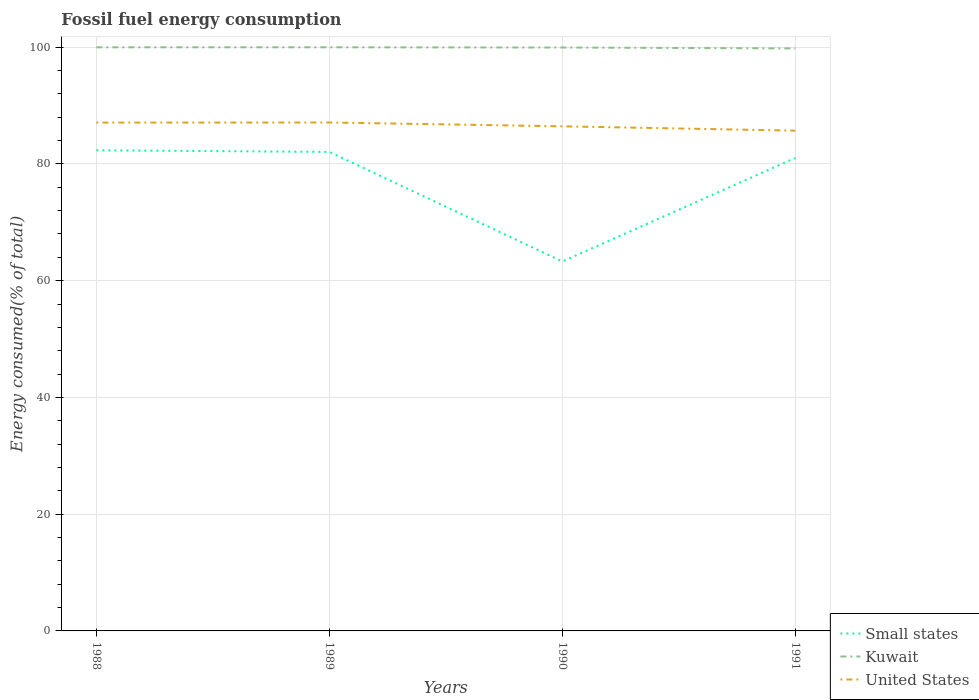How many different coloured lines are there?
Give a very brief answer. 3. Across all years, what is the maximum percentage of energy consumed in United States?
Provide a succinct answer. 85.69. In which year was the percentage of energy consumed in United States maximum?
Ensure brevity in your answer.  1991. What is the total percentage of energy consumed in Small states in the graph?
Your answer should be compact. 19.04. What is the difference between the highest and the second highest percentage of energy consumed in United States?
Your response must be concise. 1.4. What is the difference between the highest and the lowest percentage of energy consumed in Small states?
Provide a succinct answer. 3. How many lines are there?
Keep it short and to the point. 3. How many years are there in the graph?
Make the answer very short. 4. Where does the legend appear in the graph?
Your response must be concise. Bottom right. What is the title of the graph?
Keep it short and to the point. Fossil fuel energy consumption. Does "Macao" appear as one of the legend labels in the graph?
Keep it short and to the point. No. What is the label or title of the X-axis?
Offer a terse response. Years. What is the label or title of the Y-axis?
Offer a terse response. Energy consumed(% of total). What is the Energy consumed(% of total) of Small states in 1988?
Your answer should be compact. 82.33. What is the Energy consumed(% of total) of Kuwait in 1988?
Ensure brevity in your answer.  99.97. What is the Energy consumed(% of total) of United States in 1988?
Provide a short and direct response. 87.08. What is the Energy consumed(% of total) of Small states in 1989?
Your answer should be very brief. 82.05. What is the Energy consumed(% of total) in Kuwait in 1989?
Offer a very short reply. 99.98. What is the Energy consumed(% of total) of United States in 1989?
Offer a very short reply. 87.09. What is the Energy consumed(% of total) in Small states in 1990?
Provide a succinct answer. 63.29. What is the Energy consumed(% of total) in Kuwait in 1990?
Your answer should be compact. 99.94. What is the Energy consumed(% of total) of United States in 1990?
Your response must be concise. 86.44. What is the Energy consumed(% of total) in Small states in 1991?
Offer a very short reply. 81.03. What is the Energy consumed(% of total) of Kuwait in 1991?
Offer a very short reply. 99.78. What is the Energy consumed(% of total) of United States in 1991?
Provide a short and direct response. 85.69. Across all years, what is the maximum Energy consumed(% of total) in Small states?
Keep it short and to the point. 82.33. Across all years, what is the maximum Energy consumed(% of total) of Kuwait?
Ensure brevity in your answer.  99.98. Across all years, what is the maximum Energy consumed(% of total) in United States?
Ensure brevity in your answer.  87.09. Across all years, what is the minimum Energy consumed(% of total) of Small states?
Give a very brief answer. 63.29. Across all years, what is the minimum Energy consumed(% of total) of Kuwait?
Give a very brief answer. 99.78. Across all years, what is the minimum Energy consumed(% of total) in United States?
Keep it short and to the point. 85.69. What is the total Energy consumed(% of total) of Small states in the graph?
Offer a terse response. 308.7. What is the total Energy consumed(% of total) in Kuwait in the graph?
Give a very brief answer. 399.66. What is the total Energy consumed(% of total) in United States in the graph?
Give a very brief answer. 346.3. What is the difference between the Energy consumed(% of total) of Small states in 1988 and that in 1989?
Offer a very short reply. 0.28. What is the difference between the Energy consumed(% of total) of Kuwait in 1988 and that in 1989?
Provide a short and direct response. -0. What is the difference between the Energy consumed(% of total) of United States in 1988 and that in 1989?
Ensure brevity in your answer.  -0.02. What is the difference between the Energy consumed(% of total) of Small states in 1988 and that in 1990?
Your answer should be very brief. 19.04. What is the difference between the Energy consumed(% of total) in Kuwait in 1988 and that in 1990?
Provide a short and direct response. 0.04. What is the difference between the Energy consumed(% of total) of United States in 1988 and that in 1990?
Your answer should be very brief. 0.64. What is the difference between the Energy consumed(% of total) in Small states in 1988 and that in 1991?
Keep it short and to the point. 1.31. What is the difference between the Energy consumed(% of total) of Kuwait in 1988 and that in 1991?
Keep it short and to the point. 0.19. What is the difference between the Energy consumed(% of total) in United States in 1988 and that in 1991?
Your response must be concise. 1.38. What is the difference between the Energy consumed(% of total) in Small states in 1989 and that in 1990?
Provide a short and direct response. 18.76. What is the difference between the Energy consumed(% of total) of Kuwait in 1989 and that in 1990?
Your response must be concise. 0.04. What is the difference between the Energy consumed(% of total) of United States in 1989 and that in 1990?
Provide a succinct answer. 0.66. What is the difference between the Energy consumed(% of total) in Small states in 1989 and that in 1991?
Provide a succinct answer. 1.02. What is the difference between the Energy consumed(% of total) of Kuwait in 1989 and that in 1991?
Offer a very short reply. 0.19. What is the difference between the Energy consumed(% of total) of United States in 1989 and that in 1991?
Provide a succinct answer. 1.4. What is the difference between the Energy consumed(% of total) in Small states in 1990 and that in 1991?
Your answer should be very brief. -17.74. What is the difference between the Energy consumed(% of total) of Kuwait in 1990 and that in 1991?
Give a very brief answer. 0.15. What is the difference between the Energy consumed(% of total) in United States in 1990 and that in 1991?
Provide a short and direct response. 0.74. What is the difference between the Energy consumed(% of total) in Small states in 1988 and the Energy consumed(% of total) in Kuwait in 1989?
Make the answer very short. -17.64. What is the difference between the Energy consumed(% of total) of Small states in 1988 and the Energy consumed(% of total) of United States in 1989?
Your answer should be very brief. -4.76. What is the difference between the Energy consumed(% of total) of Kuwait in 1988 and the Energy consumed(% of total) of United States in 1989?
Offer a very short reply. 12.88. What is the difference between the Energy consumed(% of total) of Small states in 1988 and the Energy consumed(% of total) of Kuwait in 1990?
Offer a very short reply. -17.6. What is the difference between the Energy consumed(% of total) of Small states in 1988 and the Energy consumed(% of total) of United States in 1990?
Keep it short and to the point. -4.11. What is the difference between the Energy consumed(% of total) of Kuwait in 1988 and the Energy consumed(% of total) of United States in 1990?
Make the answer very short. 13.53. What is the difference between the Energy consumed(% of total) in Small states in 1988 and the Energy consumed(% of total) in Kuwait in 1991?
Provide a short and direct response. -17.45. What is the difference between the Energy consumed(% of total) of Small states in 1988 and the Energy consumed(% of total) of United States in 1991?
Provide a succinct answer. -3.36. What is the difference between the Energy consumed(% of total) in Kuwait in 1988 and the Energy consumed(% of total) in United States in 1991?
Make the answer very short. 14.28. What is the difference between the Energy consumed(% of total) of Small states in 1989 and the Energy consumed(% of total) of Kuwait in 1990?
Your answer should be very brief. -17.88. What is the difference between the Energy consumed(% of total) in Small states in 1989 and the Energy consumed(% of total) in United States in 1990?
Your response must be concise. -4.39. What is the difference between the Energy consumed(% of total) of Kuwait in 1989 and the Energy consumed(% of total) of United States in 1990?
Ensure brevity in your answer.  13.54. What is the difference between the Energy consumed(% of total) of Small states in 1989 and the Energy consumed(% of total) of Kuwait in 1991?
Your answer should be very brief. -17.73. What is the difference between the Energy consumed(% of total) in Small states in 1989 and the Energy consumed(% of total) in United States in 1991?
Ensure brevity in your answer.  -3.64. What is the difference between the Energy consumed(% of total) of Kuwait in 1989 and the Energy consumed(% of total) of United States in 1991?
Offer a very short reply. 14.28. What is the difference between the Energy consumed(% of total) in Small states in 1990 and the Energy consumed(% of total) in Kuwait in 1991?
Your answer should be very brief. -36.49. What is the difference between the Energy consumed(% of total) of Small states in 1990 and the Energy consumed(% of total) of United States in 1991?
Keep it short and to the point. -22.41. What is the difference between the Energy consumed(% of total) in Kuwait in 1990 and the Energy consumed(% of total) in United States in 1991?
Your response must be concise. 14.24. What is the average Energy consumed(% of total) of Small states per year?
Offer a very short reply. 77.17. What is the average Energy consumed(% of total) in Kuwait per year?
Give a very brief answer. 99.92. What is the average Energy consumed(% of total) of United States per year?
Offer a terse response. 86.58. In the year 1988, what is the difference between the Energy consumed(% of total) of Small states and Energy consumed(% of total) of Kuwait?
Give a very brief answer. -17.64. In the year 1988, what is the difference between the Energy consumed(% of total) in Small states and Energy consumed(% of total) in United States?
Offer a terse response. -4.75. In the year 1988, what is the difference between the Energy consumed(% of total) in Kuwait and Energy consumed(% of total) in United States?
Your answer should be compact. 12.89. In the year 1989, what is the difference between the Energy consumed(% of total) of Small states and Energy consumed(% of total) of Kuwait?
Offer a very short reply. -17.92. In the year 1989, what is the difference between the Energy consumed(% of total) in Small states and Energy consumed(% of total) in United States?
Ensure brevity in your answer.  -5.04. In the year 1989, what is the difference between the Energy consumed(% of total) in Kuwait and Energy consumed(% of total) in United States?
Offer a terse response. 12.88. In the year 1990, what is the difference between the Energy consumed(% of total) in Small states and Energy consumed(% of total) in Kuwait?
Offer a terse response. -36.65. In the year 1990, what is the difference between the Energy consumed(% of total) in Small states and Energy consumed(% of total) in United States?
Make the answer very short. -23.15. In the year 1990, what is the difference between the Energy consumed(% of total) in Kuwait and Energy consumed(% of total) in United States?
Keep it short and to the point. 13.5. In the year 1991, what is the difference between the Energy consumed(% of total) of Small states and Energy consumed(% of total) of Kuwait?
Make the answer very short. -18.76. In the year 1991, what is the difference between the Energy consumed(% of total) in Small states and Energy consumed(% of total) in United States?
Make the answer very short. -4.67. In the year 1991, what is the difference between the Energy consumed(% of total) of Kuwait and Energy consumed(% of total) of United States?
Make the answer very short. 14.09. What is the ratio of the Energy consumed(% of total) of Small states in 1988 to that in 1989?
Provide a short and direct response. 1. What is the ratio of the Energy consumed(% of total) of Kuwait in 1988 to that in 1989?
Provide a succinct answer. 1. What is the ratio of the Energy consumed(% of total) in Small states in 1988 to that in 1990?
Your response must be concise. 1.3. What is the ratio of the Energy consumed(% of total) in United States in 1988 to that in 1990?
Give a very brief answer. 1.01. What is the ratio of the Energy consumed(% of total) in Small states in 1988 to that in 1991?
Your answer should be compact. 1.02. What is the ratio of the Energy consumed(% of total) of Kuwait in 1988 to that in 1991?
Ensure brevity in your answer.  1. What is the ratio of the Energy consumed(% of total) of United States in 1988 to that in 1991?
Offer a very short reply. 1.02. What is the ratio of the Energy consumed(% of total) of Small states in 1989 to that in 1990?
Your answer should be very brief. 1.3. What is the ratio of the Energy consumed(% of total) of United States in 1989 to that in 1990?
Your answer should be very brief. 1.01. What is the ratio of the Energy consumed(% of total) of Small states in 1989 to that in 1991?
Offer a very short reply. 1.01. What is the ratio of the Energy consumed(% of total) in Kuwait in 1989 to that in 1991?
Your response must be concise. 1. What is the ratio of the Energy consumed(% of total) in United States in 1989 to that in 1991?
Your answer should be compact. 1.02. What is the ratio of the Energy consumed(% of total) in Small states in 1990 to that in 1991?
Keep it short and to the point. 0.78. What is the ratio of the Energy consumed(% of total) of United States in 1990 to that in 1991?
Provide a succinct answer. 1.01. What is the difference between the highest and the second highest Energy consumed(% of total) of Small states?
Keep it short and to the point. 0.28. What is the difference between the highest and the second highest Energy consumed(% of total) of Kuwait?
Keep it short and to the point. 0. What is the difference between the highest and the second highest Energy consumed(% of total) of United States?
Provide a short and direct response. 0.02. What is the difference between the highest and the lowest Energy consumed(% of total) in Small states?
Provide a short and direct response. 19.04. What is the difference between the highest and the lowest Energy consumed(% of total) of Kuwait?
Your response must be concise. 0.19. What is the difference between the highest and the lowest Energy consumed(% of total) in United States?
Offer a very short reply. 1.4. 